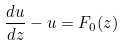<formula> <loc_0><loc_0><loc_500><loc_500>\frac { d u } { d z } - u = F _ { 0 } ( z )</formula> 